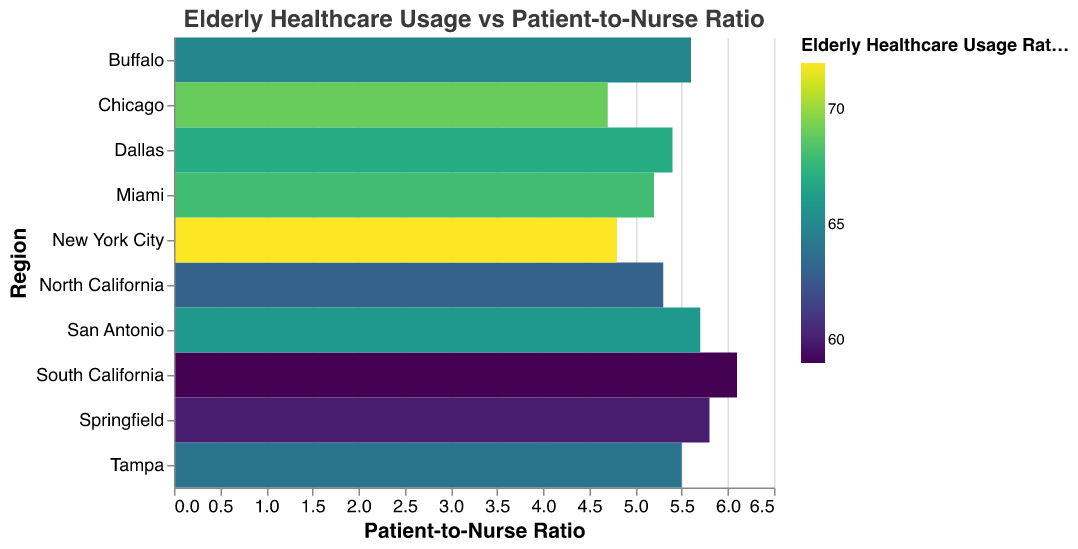What is the title of the heatmap? The title is displayed at the top of the heatmap. It reads "Elderly Healthcare Usage vs Patient-to-Nurse Ratio".
Answer: Elderly Healthcare Usage vs Patient-to-Nurse Ratio Which region has the highest elderly healthcare usage rate? By observing the colors and values associated with each region, New York City has the darkest color representing the highest rate. The label also confirms that New York City has a usage rate of 72%.
Answer: New York City What is the Patient-to-Nurse ratio for Chicago? Locate the Chicago row and find the corresponding value in the Patient-to-Nurse Ratio column. The value is 4.7.
Answer: 4.7 Which region has the lowest Patient-to-Nurse ratio? Compare all Patient-to-Nurse ratio values and identify the smallest number. Chicago has the lowest ratio with a value of 4.7.
Answer: Chicago What is the average Patient-to-Nurse ratio across all regions? Sum all the Patient-to-Nurse ratios (5.3 + 6.1 + 4.8 + 5.6 + 5.2 + 5.5 + 4.7 + 5.8 + 5.4 + 5.7) and divide by the number of regions (10). The total is 53.1, and the average is 53.1 / 10 = 5.31.
Answer: 5.31 Is there a region where the elderly healthcare usage rate is above 70%? Check if any region has an elderly healthcare usage rate greater than 70%. New York City has a rate of 72%, which satisfies this condition.
Answer: Yes Which regions have a Patient-to-Nurse ratio above 5.5? Identify the regions with a ratio greater than 5.5. South California (6.1), Springfield (5.8), and San Antonio (5.7) meet this criterion.
Answer: South California, Springfield, San Antonio Which region has both an above-average elderly healthcare usage rate and an above-average Patient-to-Nurse ratio? First, calculate the average rates: average elderly healthcare usage is (63+59+72+65+68+64+69+60+67+66)/10 = 65.3, and average Patient-to-Nurse ratio is 5.31. Compare each region's values against these averages. Miami (68, 5.2) meets the condition for usage rate but not for ratio above average, so no region meets both conditions.
Answer: None How do the elderly healthcare usage rates compare between North California and South California? Compare the usage rates for North California (63%) and South California (59%). North California has a higher rate than South California.
Answer: North California has a higher rate than South California What is the relationship between Patient-to-Nurse ratio and elderly healthcare usage rate across regions? Observing the heatmap, there does not appear to be a strong visual correlation between the Patient-to-Nurse ratio and elderly healthcare usage rates. Regions with both high and low Patient-to-Nurse ratios show varying usage rates.
Answer: No strong correlation 